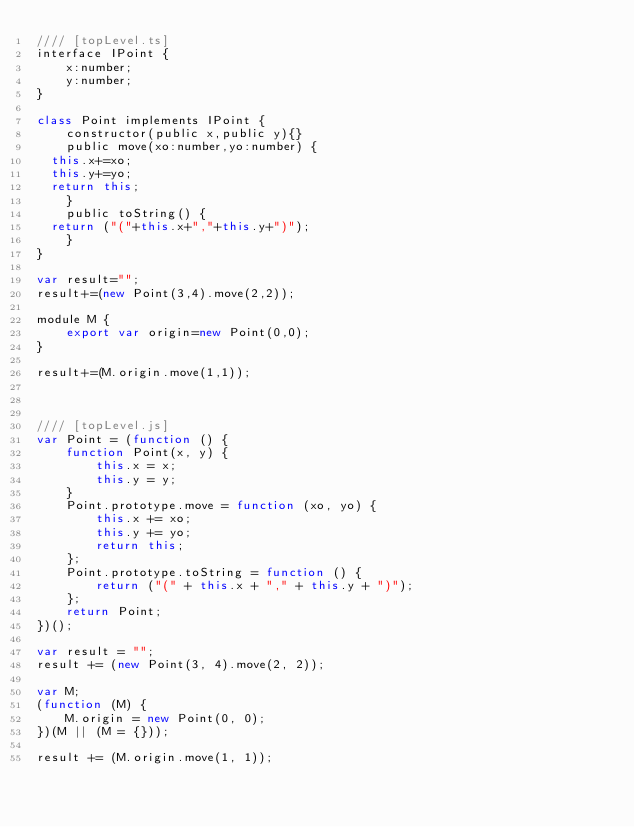Convert code to text. <code><loc_0><loc_0><loc_500><loc_500><_JavaScript_>//// [topLevel.ts]
interface IPoint {
    x:number;
    y:number;
}

class Point implements IPoint {
    constructor(public x,public y){}
    public move(xo:number,yo:number) {
	this.x+=xo;
	this.y+=yo;
	return this;
    }
    public toString() {
	return ("("+this.x+","+this.y+")");
    }
}

var result="";
result+=(new Point(3,4).move(2,2));

module M {
    export var origin=new Point(0,0);
}

result+=(M.origin.move(1,1));



//// [topLevel.js]
var Point = (function () {
    function Point(x, y) {
        this.x = x;
        this.y = y;
    }
    Point.prototype.move = function (xo, yo) {
        this.x += xo;
        this.y += yo;
        return this;
    };
    Point.prototype.toString = function () {
        return ("(" + this.x + "," + this.y + ")");
    };
    return Point;
})();

var result = "";
result += (new Point(3, 4).move(2, 2));

var M;
(function (M) {
    M.origin = new Point(0, 0);
})(M || (M = {}));

result += (M.origin.move(1, 1));
</code> 